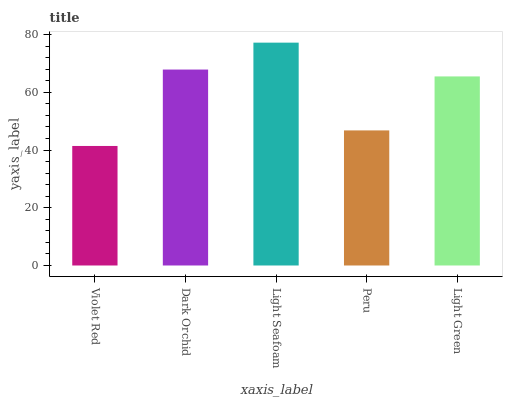Is Violet Red the minimum?
Answer yes or no. Yes. Is Light Seafoam the maximum?
Answer yes or no. Yes. Is Dark Orchid the minimum?
Answer yes or no. No. Is Dark Orchid the maximum?
Answer yes or no. No. Is Dark Orchid greater than Violet Red?
Answer yes or no. Yes. Is Violet Red less than Dark Orchid?
Answer yes or no. Yes. Is Violet Red greater than Dark Orchid?
Answer yes or no. No. Is Dark Orchid less than Violet Red?
Answer yes or no. No. Is Light Green the high median?
Answer yes or no. Yes. Is Light Green the low median?
Answer yes or no. Yes. Is Violet Red the high median?
Answer yes or no. No. Is Light Seafoam the low median?
Answer yes or no. No. 